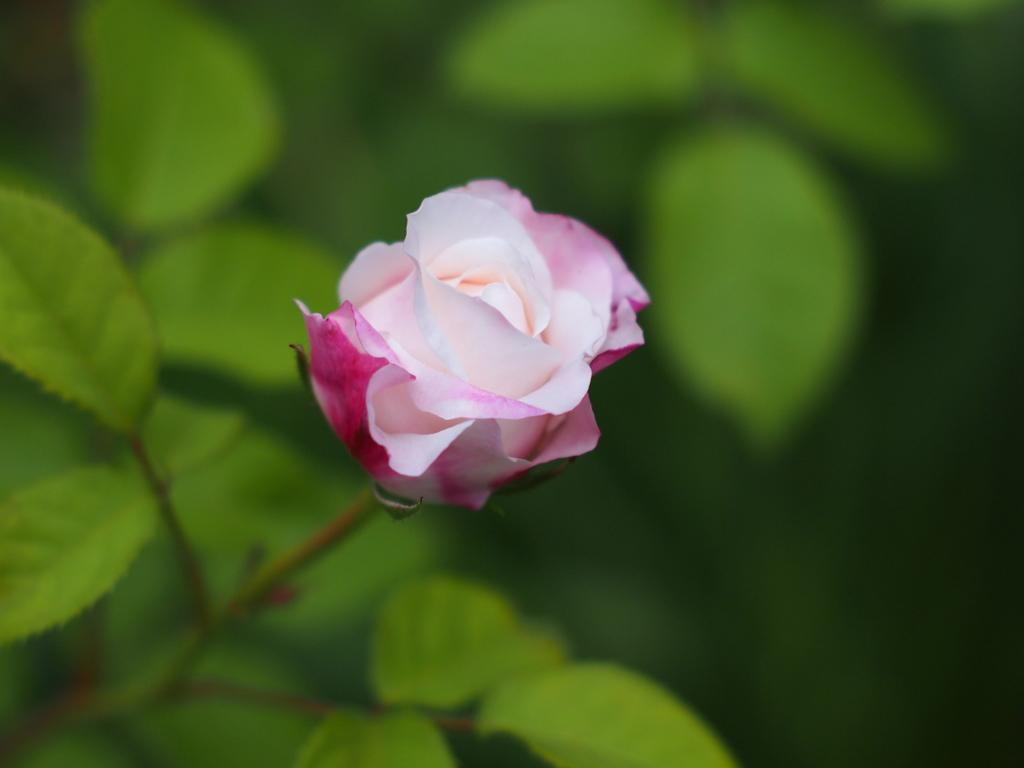What type of plant is in the image? There is a rose plant in the image. What part of the plant is visible in the image? There are leaves visible in the image. What type of cracker is being used to flavor the rose plant in the image? There is no cracker present in the image, and the rose plant is not being flavored. 